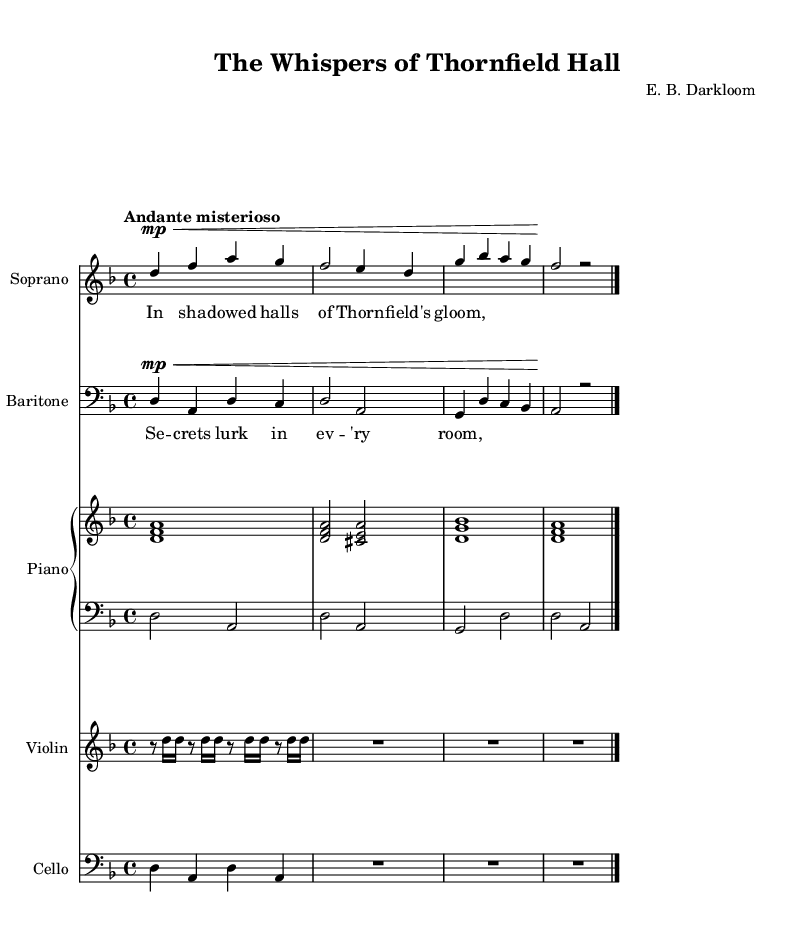What is the key signature of this music? The music is in D minor, as indicated by the "d" key signature which includes one flat (B flat).
Answer: D minor What is the time signature of this piece? The time signature shown is 4/4, which means there are four beats in each measure, and the quarter note gets one beat.
Answer: 4/4 What is the tempo marking of this composition? The tempo marking is "Andante misterioso," suggesting a moderate and mysterious pace.
Answer: Andante misterioso How many voices are present in this score? There are two distinct voices: soprano and baritone, as indicated in the separate staves for each.
Answer: Two What are the thematic elements described in the soprano lyrics? The soprano lyrics reference "shadows" and "gloom," suggesting a dark and mysterious theme, typical for Gothic operas.
Answer: Shadows and gloom Which instrument has the highest pitch in this score? The soprano part, being notated in a higher range than the other instruments, carries the highest pitch as it is typically written in treble clef.
Answer: Soprano What is the harmonic relationship between the soprano and baritone parts? The soprano and baritone parts often interact in a way that creates harmonies, suggesting a duet where they sing together in intervals.
Answer: Duet harmony 